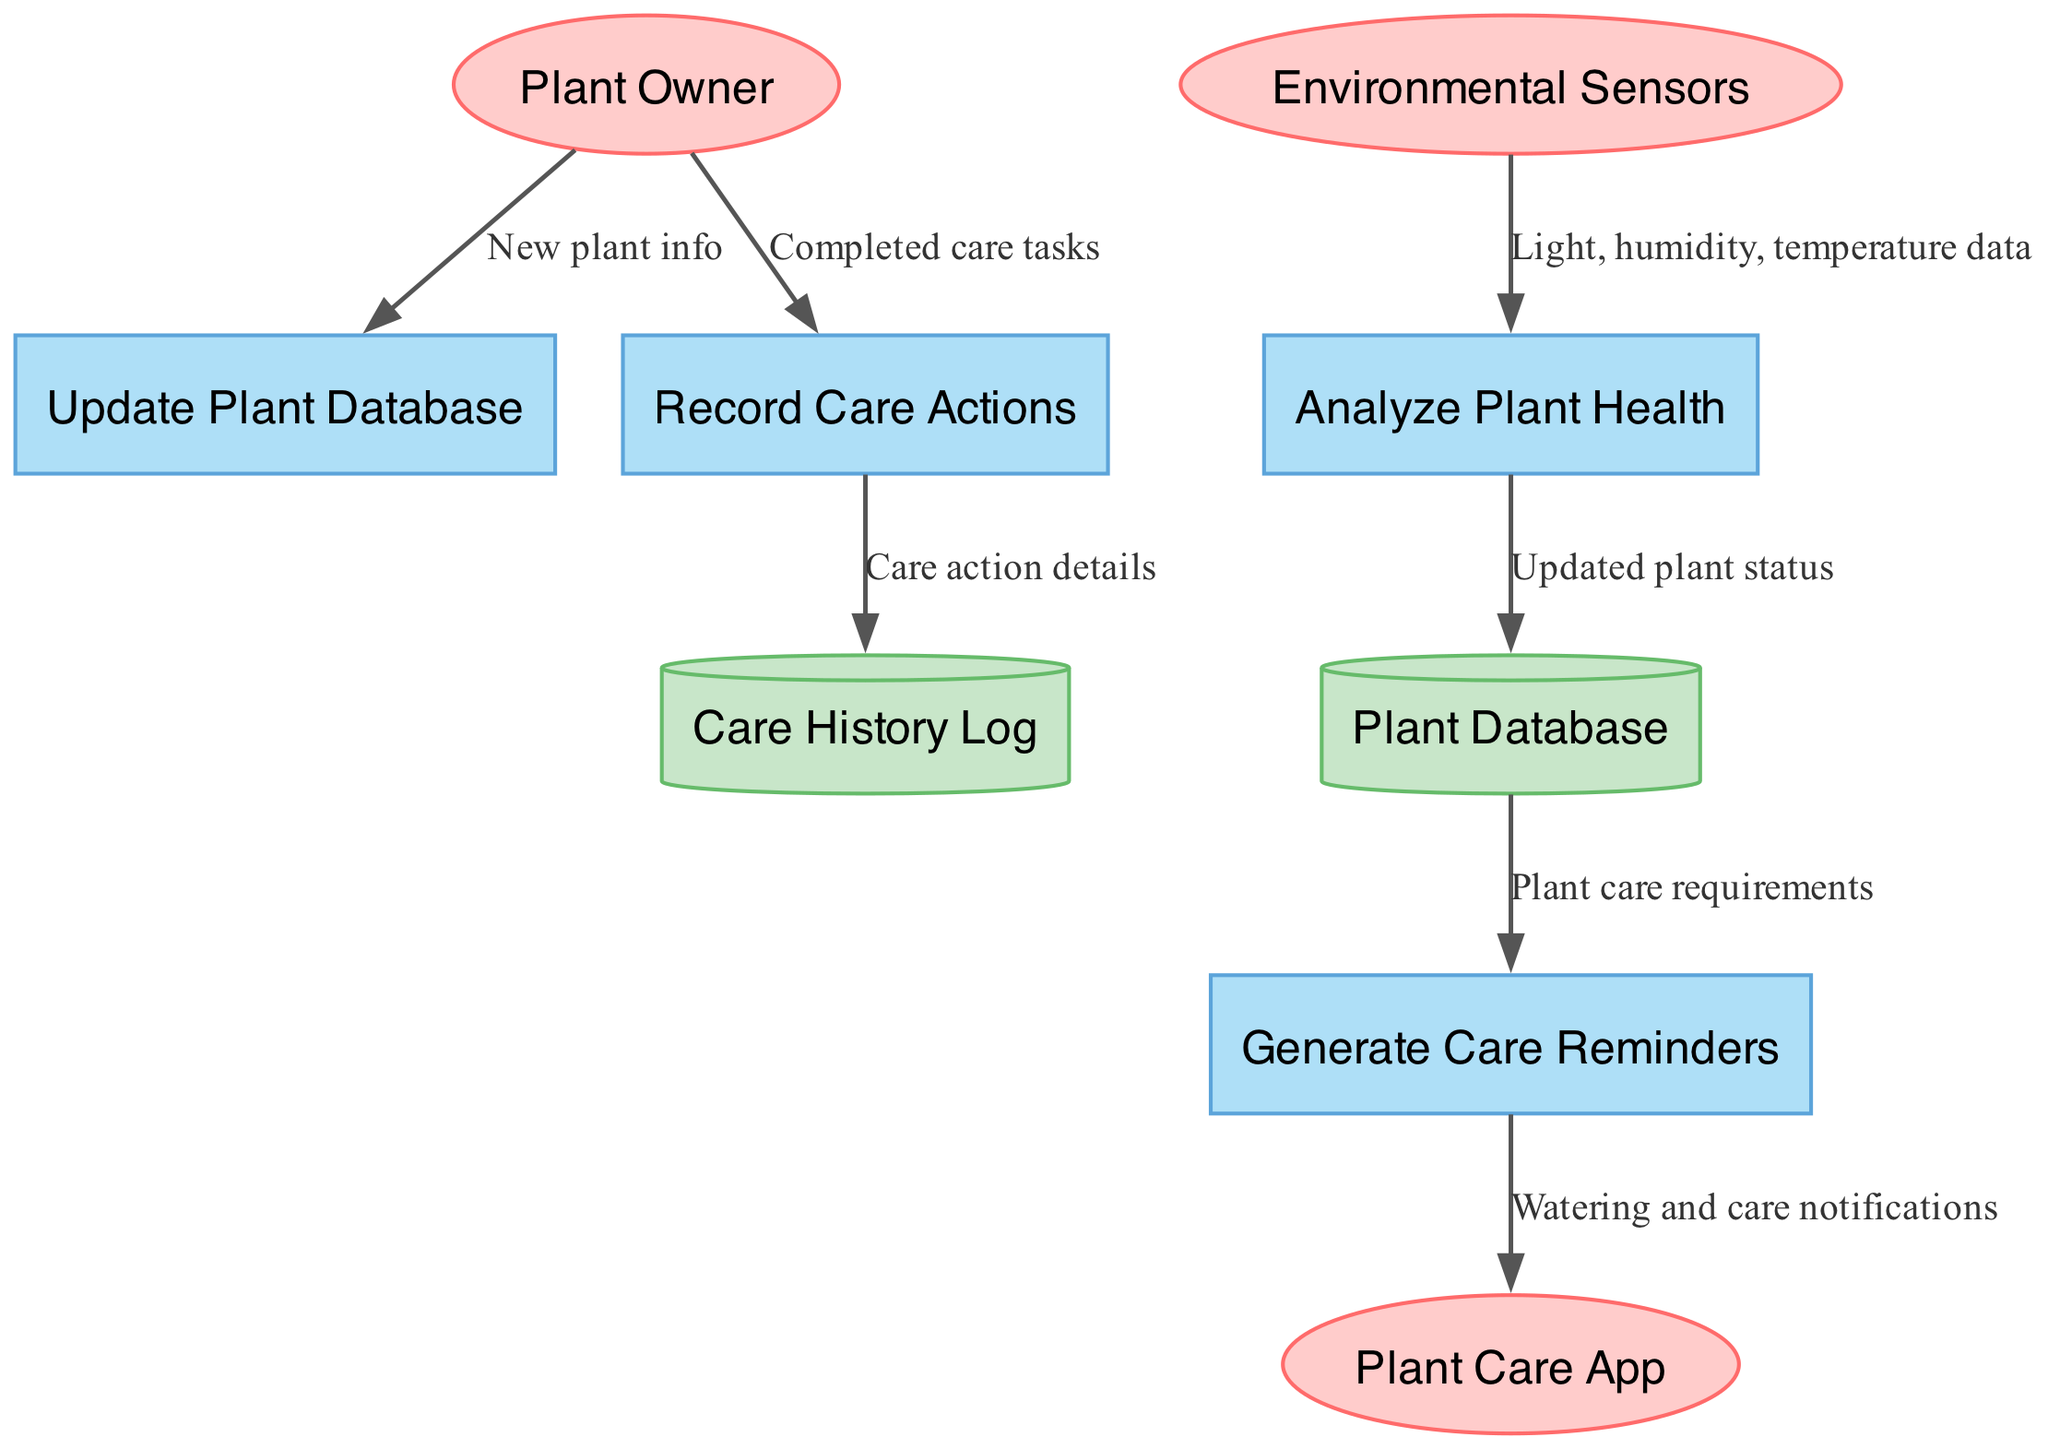What are the external entities in the diagram? The external entities are represented as ellipses and include "Plant Owner," "Plant Care App," and "Environmental Sensors."
Answer: Plant Owner, Plant Care App, Environmental Sensors How many processes are defined in the diagram? The processes are indicated by the rectangles in the diagram, and there are four listed processes: "Update Plant Database," "Generate Care Reminders," "Analyze Plant Health," and "Record Care Actions."
Answer: 4 Which process receives light, humidity, and temperature data? The data flow from "Environmental Sensors" points towards "Analyze Plant Health," indicating that this process is responsible for processing that specific data.
Answer: Analyze Plant Health What type of data store is "Care History Log"? "Care History Log" is represented as a cylinder in the diagram, which is the standard shape used to depict data stores in Data Flow Diagrams.
Answer: Cylinder From which node does "Watering and care notifications" flow into the app? The notification data flows from the "Generate Care Reminders" process to the "Plant Care App," indicating that it is the source of notifications for care tasks.
Answer: Generate Care Reminders Which entity provides new plant information to the system? The "Plant Owner" is the entity that initiates the flow by providing new plant info to the "Update Plant Database" process, making them the source of this information.
Answer: Plant Owner What is the relationship between "Record Care Actions" and "Care History Log"? There is a directed flow from "Record Care Actions" to "Care History Log," indicating that the details of care actions recorded are stored in the Care History Log data store.
Answer: Directed flow How many data stores are present in the diagram? The diagram includes two data stores: "Plant Database" and "Care History Log," which are depicted as cylinders and signify where data is stored.
Answer: 2 What type of data does "Update Plant Database" process receive? The "Update Plant Database" process receives "New plant info" from the "Plant Owner," which denotes the kind of information being input into the system.
Answer: New plant info 